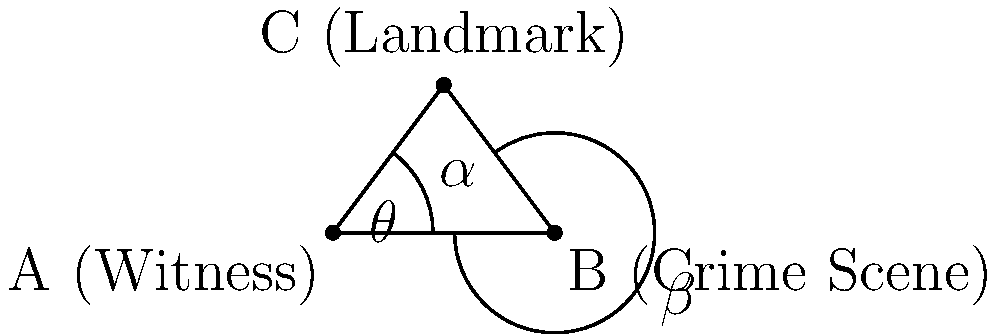In a cold case you're reviewing, a witness claims to have seen a landmark from the crime scene. Given the positions of the witness (A), crime scene (B), and landmark (C) form a triangle with sides AB = 6 units, AC = 5 units, and BC = 5 units, what is the approximate viewing angle ($\theta$) of the witness in degrees? To solve this problem, we'll use the law of cosines and basic trigonometry:

1) First, we need to find the angle $\alpha$ at point A using the law of cosines:
   $\cos(\alpha) = \frac{AC^2 + AB^2 - BC^2}{2(AC)(AB)}$
   
   $\cos(\alpha) = \frac{5^2 + 6^2 - 5^2}{2(5)(6)} = \frac{36}{60} = 0.6$

2) Now we can find $\alpha$ using the inverse cosine function:
   $\alpha = \arccos(0.6) \approx 53.13°$

3) The viewing angle $\theta$ is the supplementary angle to $\alpha$:
   $\theta = 180° - \alpha$

4) Substituting the value we found for $\alpha$:
   $\theta = 180° - 53.13° \approx 126.87°$

5) Rounding to the nearest degree:
   $\theta \approx 127°$
Answer: 127° 